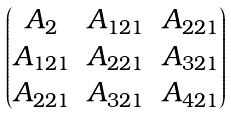<formula> <loc_0><loc_0><loc_500><loc_500>\begin{pmatrix} A _ { 2 } & A _ { 1 2 1 } & A _ { 2 2 1 } \\ A _ { 1 2 1 } & A _ { 2 2 1 } & A _ { 3 2 1 } \\ A _ { 2 2 1 } & A _ { 3 2 1 } & A _ { 4 2 1 } \end{pmatrix}</formula> 